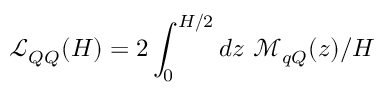Convert formula to latex. <formula><loc_0><loc_0><loc_500><loc_500>\mathcal { L } _ { Q Q } ( { H } ) = 2 \int _ { 0 } ^ { { H } / 2 } d z \ \mathcal { M } _ { q Q } ( z ) / H</formula> 